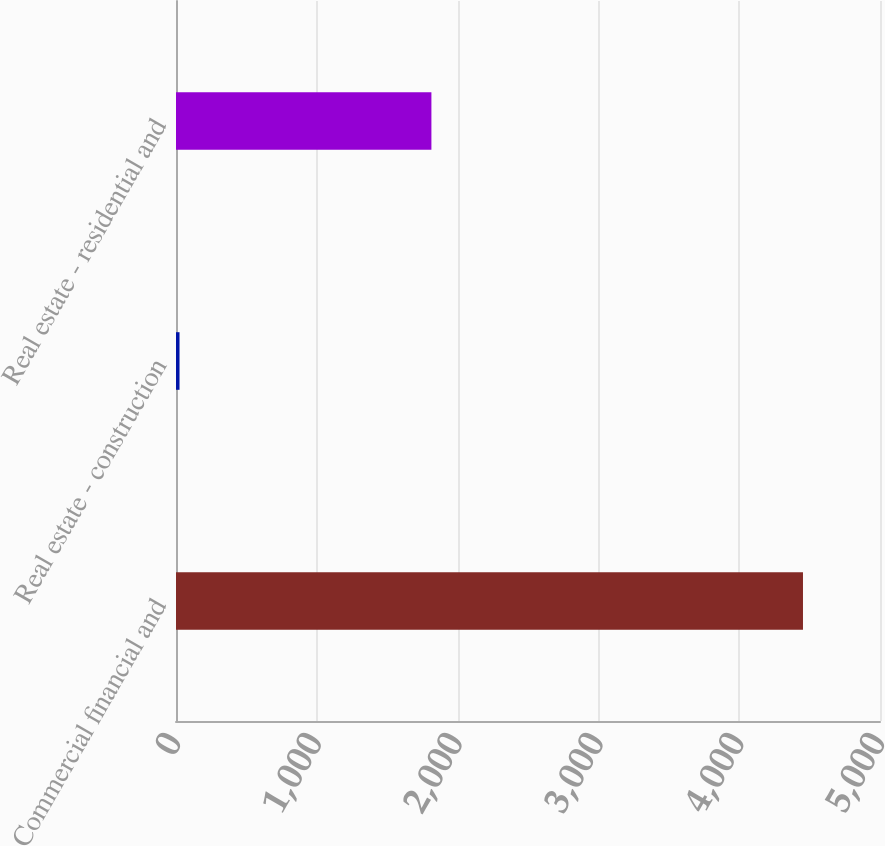Convert chart. <chart><loc_0><loc_0><loc_500><loc_500><bar_chart><fcel>Commercial financial and<fcel>Real estate - construction<fcel>Real estate - residential and<nl><fcel>4453<fcel>25<fcel>1814<nl></chart> 